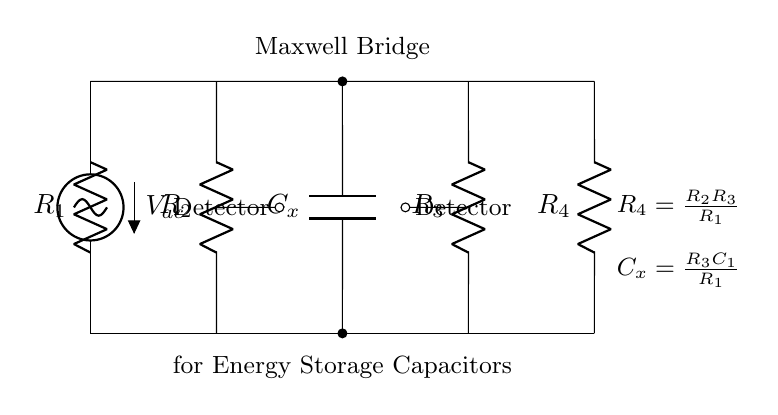What is the function of the capacitor in this circuit? The capacitor, labeled as C_x, serves as the energy storage component in the Maxwell bridge configuration. It is essential for evaluating energy storage characteristics in smart grid applications.
Answer: Energy storage What is the mathematical relationship of R4 in the Maxwell bridge? The circuit indicates that R4 is defined as the product of R2 and R3 divided by R1, following the bridge equation which maintains a balance in the bridge.
Answer: R4 = R2R3/R1 What is the type of voltage supplied in the circuit? The circuit is supplied with an alternating current voltage labeled V_ac, which is typically used for bridges in evaluation contexts, ensuring dynamic behavior in the measurements.
Answer: Alternating current How many resistors are there in this Maxwell bridge? The diagram indicates a total of four resistors (R1, R2, R3, and R4) that work together within the bridge to balance the circuit for accurate readings.
Answer: Four What does the detector do in the circuit? The detector placed between the nodes in the circuit measures the balance condition of the bridge, indicating whether the bridge is at equilibrium or requires adjustment.
Answer: Measures balance condition What does R3 represent in terms of capacitor evaluation? R3 is part of the equation involving the capacitance C_x, and it plays a crucial role in defining the experimental conditions necessary for evaluating the capacitor's properties.
Answer: Component for evaluation What is the overall purpose of the circuit? The Maxwell bridge is designed to accurately evaluate the characteristics of energy storage capacitors used in smart grids, aiding in the optimization of energy management in electrical systems.
Answer: Evaluate energy storage capacitors 